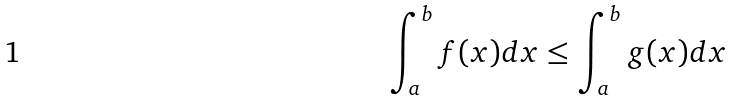<formula> <loc_0><loc_0><loc_500><loc_500>\int _ { a } ^ { b } f ( x ) d x \leq \int _ { a } ^ { b } g ( x ) d x</formula> 